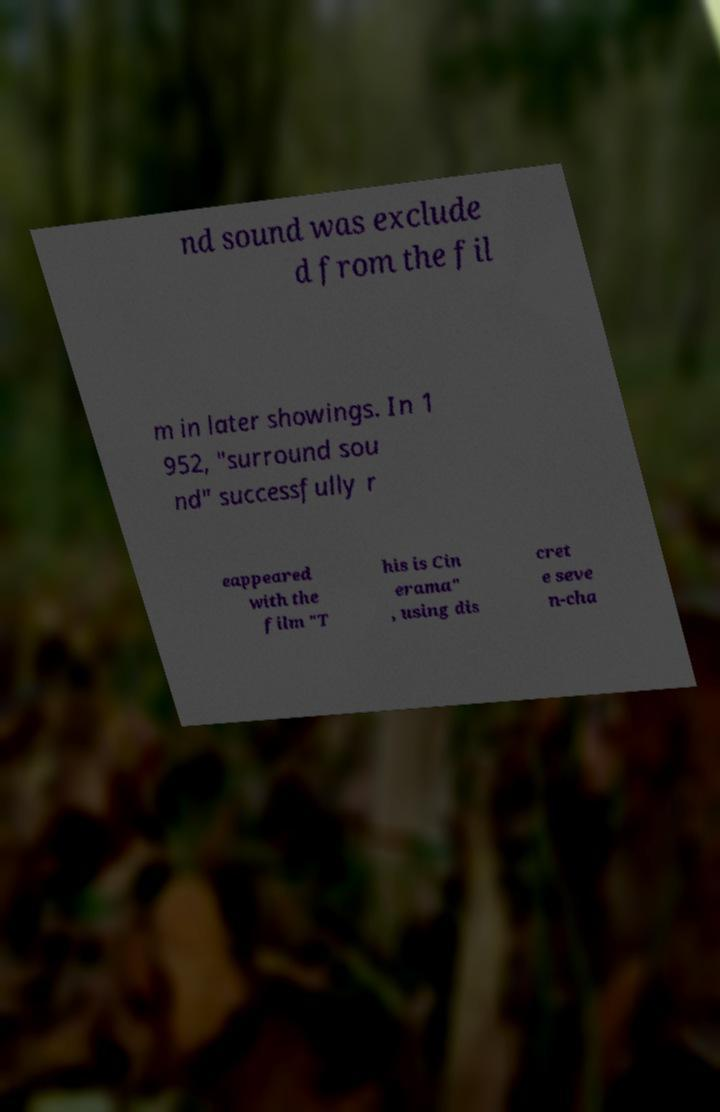Could you extract and type out the text from this image? nd sound was exclude d from the fil m in later showings. In 1 952, "surround sou nd" successfully r eappeared with the film "T his is Cin erama" , using dis cret e seve n-cha 